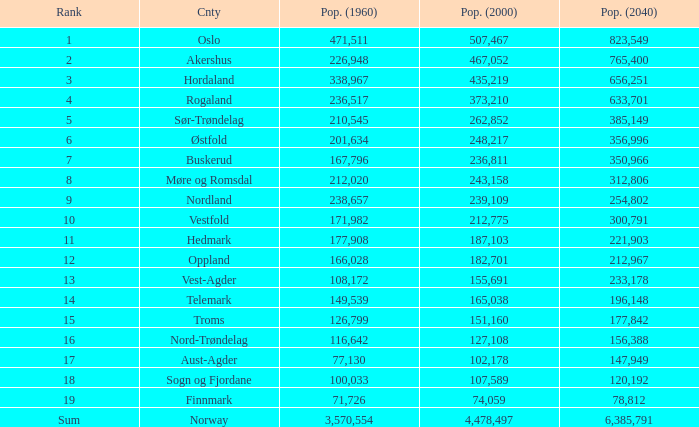What was the number of inhabitants in a county in 1960 that had 467,052 residents in 2000 and 78,812 in 2040? None. 